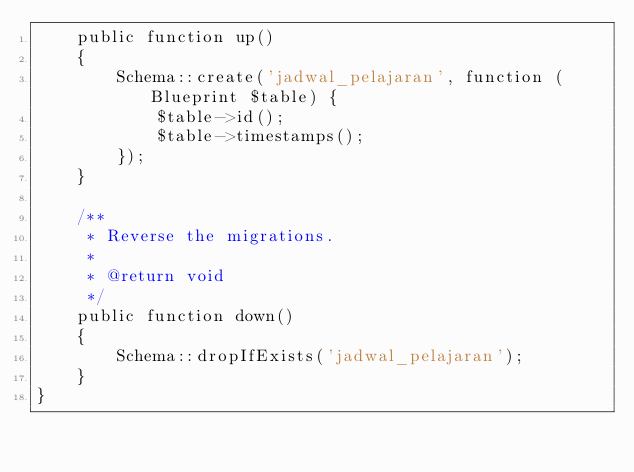<code> <loc_0><loc_0><loc_500><loc_500><_PHP_>    public function up()
    {
        Schema::create('jadwal_pelajaran', function (Blueprint $table) {
            $table->id();
            $table->timestamps();
        });
    }

    /**
     * Reverse the migrations.
     *
     * @return void
     */
    public function down()
    {
        Schema::dropIfExists('jadwal_pelajaran');
    }
}
</code> 